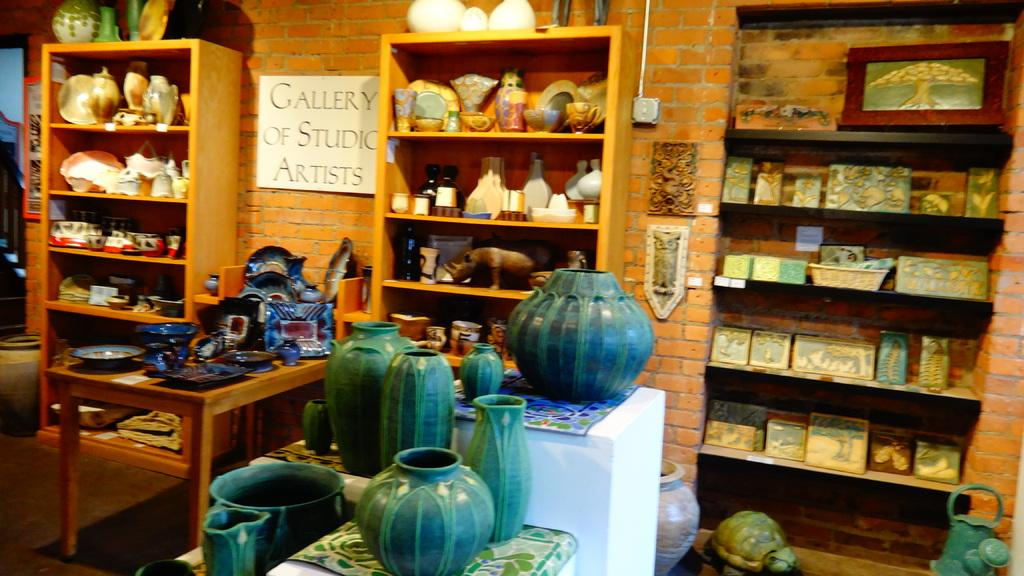<image>
Describe the image concisely. inside store full of pottery, paitings, and other items with sign on wall showing gallery of studio artists 